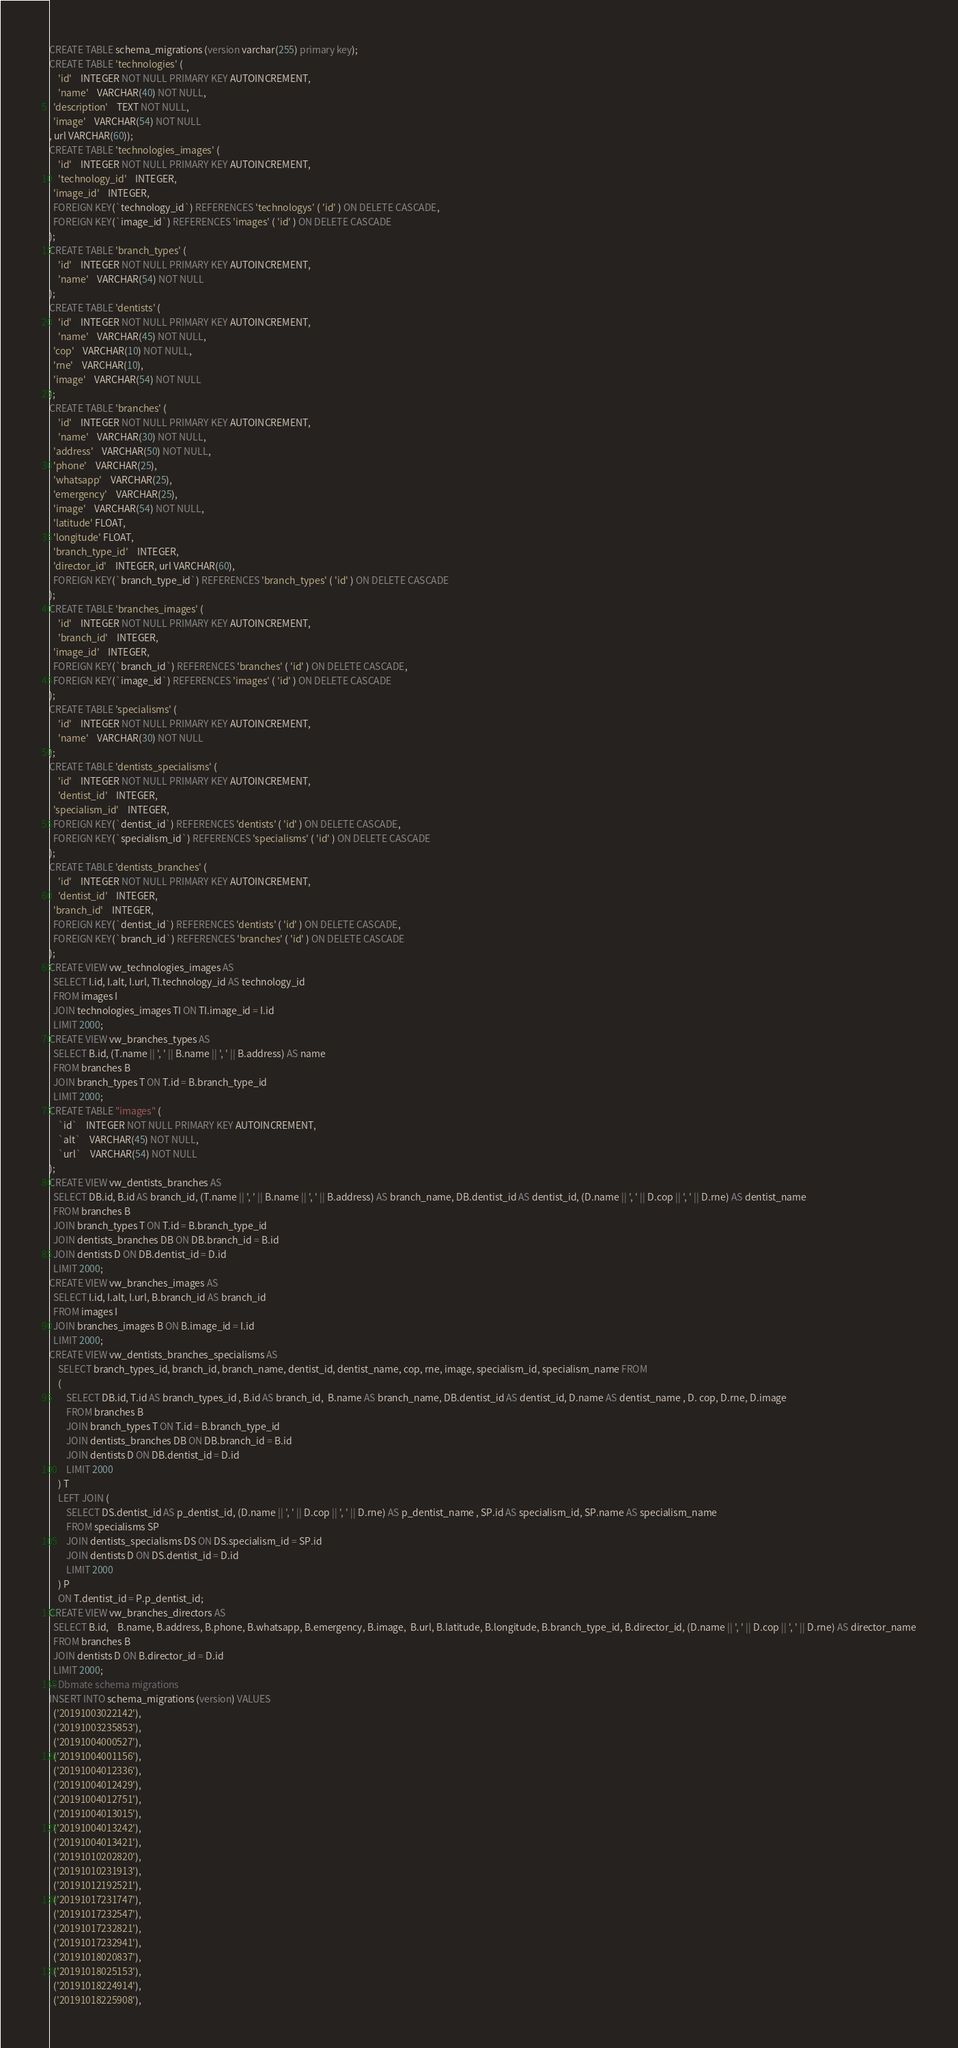Convert code to text. <code><loc_0><loc_0><loc_500><loc_500><_SQL_>CREATE TABLE schema_migrations (version varchar(255) primary key);
CREATE TABLE 'technologies' (
	'id'	INTEGER NOT NULL PRIMARY KEY AUTOINCREMENT,
	'name'	VARCHAR(40) NOT NULL,
  'description'	TEXT NOT NULL,
  'image'	VARCHAR(54) NOT NULL
, url VARCHAR(60));
CREATE TABLE 'technologies_images' (
	'id'	INTEGER NOT NULL PRIMARY KEY AUTOINCREMENT,
	'technology_id'	INTEGER,
  'image_id'	INTEGER,
  FOREIGN KEY(`technology_id`) REFERENCES 'technologys' ( 'id' ) ON DELETE CASCADE,
  FOREIGN KEY(`image_id`) REFERENCES 'images' ( 'id' ) ON DELETE CASCADE
);
CREATE TABLE 'branch_types' (
	'id'	INTEGER NOT NULL PRIMARY KEY AUTOINCREMENT,
	'name'	VARCHAR(54) NOT NULL
);
CREATE TABLE 'dentists' (
	'id'	INTEGER NOT NULL PRIMARY KEY AUTOINCREMENT,
	'name'	VARCHAR(45) NOT NULL,
  'cop'	VARCHAR(10) NOT NULL,
  'rne'	VARCHAR(10),
  'image'	VARCHAR(54) NOT NULL
);
CREATE TABLE 'branches' (
	'id'	INTEGER NOT NULL PRIMARY KEY AUTOINCREMENT,
	'name'	VARCHAR(30) NOT NULL,
  'address'	VARCHAR(50) NOT NULL,
  'phone'	VARCHAR(25),
  'whatsapp'	VARCHAR(25),
  'emergency'	VARCHAR(25),
  'image'	VARCHAR(54) NOT NULL,
  'latitude' FLOAT,
  'longitude' FLOAT,
  'branch_type_id'	INTEGER,
  'director_id'	INTEGER, url VARCHAR(60),
  FOREIGN KEY(`branch_type_id`) REFERENCES 'branch_types' ( 'id' ) ON DELETE CASCADE
);
CREATE TABLE 'branches_images' (
	'id'	INTEGER NOT NULL PRIMARY KEY AUTOINCREMENT,
	'branch_id'	INTEGER,
  'image_id'	INTEGER,
  FOREIGN KEY(`branch_id`) REFERENCES 'branches' ( 'id' ) ON DELETE CASCADE,
  FOREIGN KEY(`image_id`) REFERENCES 'images' ( 'id' ) ON DELETE CASCADE
);
CREATE TABLE 'specialisms' (
	'id'	INTEGER NOT NULL PRIMARY KEY AUTOINCREMENT,
	'name'	VARCHAR(30) NOT NULL
);
CREATE TABLE 'dentists_specialisms' (
	'id'	INTEGER NOT NULL PRIMARY KEY AUTOINCREMENT,
	'dentist_id'	INTEGER,
  'specialism_id'	INTEGER,
  FOREIGN KEY(`dentist_id`) REFERENCES 'dentists' ( 'id' ) ON DELETE CASCADE,
  FOREIGN KEY(`specialism_id`) REFERENCES 'specialisms' ( 'id' ) ON DELETE CASCADE
);
CREATE TABLE 'dentists_branches' (
	'id'	INTEGER NOT NULL PRIMARY KEY AUTOINCREMENT,
	'dentist_id'	INTEGER,
  'branch_id'	INTEGER,
  FOREIGN KEY(`dentist_id`) REFERENCES 'dentists' ( 'id' ) ON DELETE CASCADE,
  FOREIGN KEY(`branch_id`) REFERENCES 'branches' ( 'id' ) ON DELETE CASCADE
);
CREATE VIEW vw_technologies_images AS
  SELECT I.id, I.alt, I.url, TI.technology_id AS technology_id
  FROM images I
  JOIN technologies_images TI ON TI.image_id = I.id
  LIMIT 2000;
CREATE VIEW vw_branches_types AS
  SELECT B.id, (T.name || ', ' || B.name || ', ' || B.address) AS name
  FROM branches B
  JOIN branch_types T ON T.id = B.branch_type_id
  LIMIT 2000;
CREATE TABLE "images" (
	`id`	INTEGER NOT NULL PRIMARY KEY AUTOINCREMENT,
	`alt`	VARCHAR(45) NOT NULL,
	`url`	VARCHAR(54) NOT NULL
);
CREATE VIEW vw_dentists_branches AS
  SELECT DB.id, B.id AS branch_id, (T.name || ', ' || B.name || ', ' || B.address) AS branch_name, DB.dentist_id AS dentist_id, (D.name || ', ' || D.cop || ', ' || D.rne) AS dentist_name
  FROM branches B
  JOIN branch_types T ON T.id = B.branch_type_id
  JOIN dentists_branches DB ON DB.branch_id = B.id
  JOIN dentists D ON DB.dentist_id = D.id
  LIMIT 2000;
CREATE VIEW vw_branches_images AS
  SELECT I.id, I.alt, I.url, B.branch_id AS branch_id
  FROM images I
  JOIN branches_images B ON B.image_id = I.id
  LIMIT 2000;
CREATE VIEW vw_dentists_branches_specialisms AS
	SELECT branch_types_id, branch_id, branch_name, dentist_id, dentist_name, cop, rne, image, specialism_id, specialism_name FROM
	(
		SELECT DB.id, T.id AS branch_types_id , B.id AS branch_id,  B.name AS branch_name, DB.dentist_id AS dentist_id, D.name AS dentist_name , D. cop, D.rne, D.image
		FROM branches B
		JOIN branch_types T ON T.id = B.branch_type_id
		JOIN dentists_branches DB ON DB.branch_id = B.id
		JOIN dentists D ON DB.dentist_id = D.id
		LIMIT 2000
	) T
	LEFT JOIN (
		SELECT DS.dentist_id AS p_dentist_id, (D.name || ', ' || D.cop || ', ' || D.rne) AS p_dentist_name , SP.id AS specialism_id, SP.name AS specialism_name
		FROM specialisms SP
		JOIN dentists_specialisms DS ON DS.specialism_id = SP.id
		JOIN dentists D ON DS.dentist_id = D.id
		LIMIT 2000
	) P
	ON T.dentist_id = P.p_dentist_id;
CREATE VIEW vw_branches_directors AS
  SELECT B.id,	B.name, B.address, B.phone, B.whatsapp, B.emergency, B.image,  B.url, B.latitude, B.longitude, B.branch_type_id, B.director_id, (D.name || ', ' || D.cop || ', ' || D.rne) AS director_name
  FROM branches B
  JOIN dentists D ON B.director_id = D.id
  LIMIT 2000;
-- Dbmate schema migrations
INSERT INTO schema_migrations (version) VALUES
  ('20191003022142'),
  ('20191003235853'),
  ('20191004000527'),
  ('20191004001156'),
  ('20191004012336'),
  ('20191004012429'),
  ('20191004012751'),
  ('20191004013015'),
  ('20191004013242'),
  ('20191004013421'),
  ('20191010202820'),
  ('20191010231913'),
  ('20191012192521'),
  ('20191017231747'),
  ('20191017232547'),
  ('20191017232821'),
  ('20191017232941'),
  ('20191018020837'),
  ('20191018025153'),
  ('20191018224914'),
  ('20191018225908'),</code> 